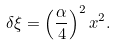Convert formula to latex. <formula><loc_0><loc_0><loc_500><loc_500>\delta \xi = \left ( \frac { \alpha } { 4 } \right ) ^ { 2 } x ^ { 2 } .</formula> 